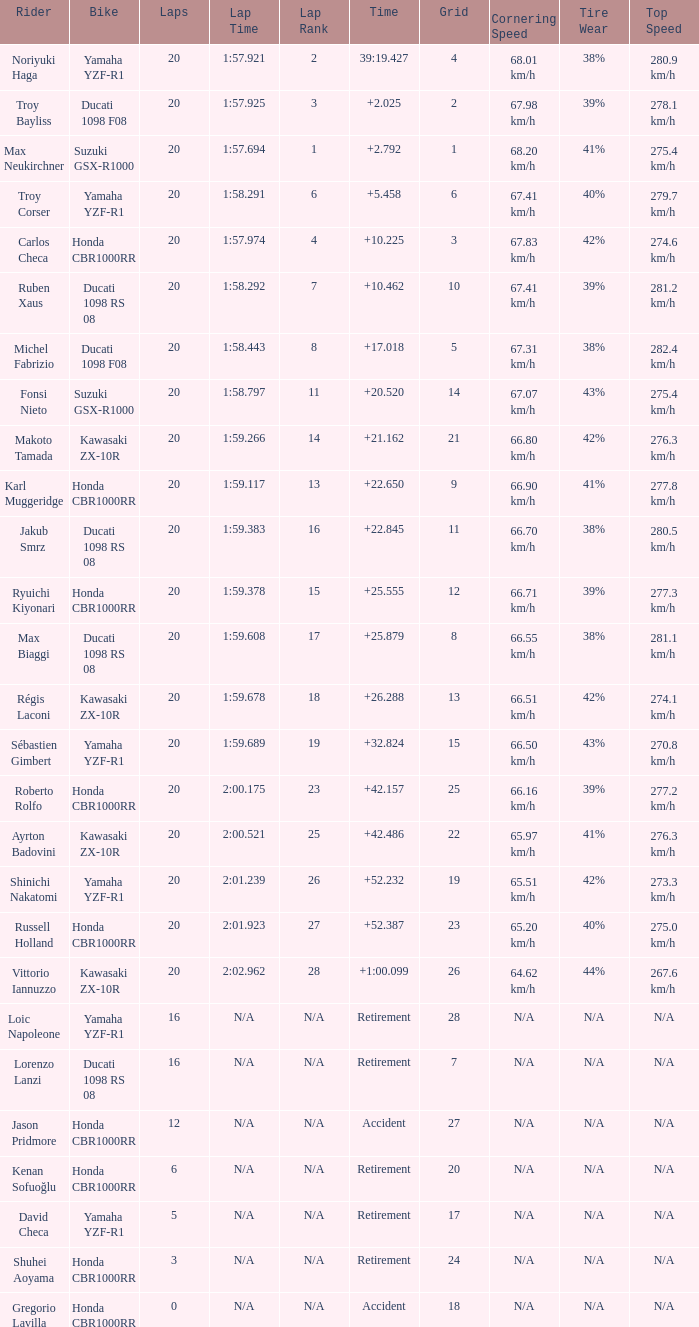What is the time of Troy Bayliss with less than 8 grids? 2.025. 